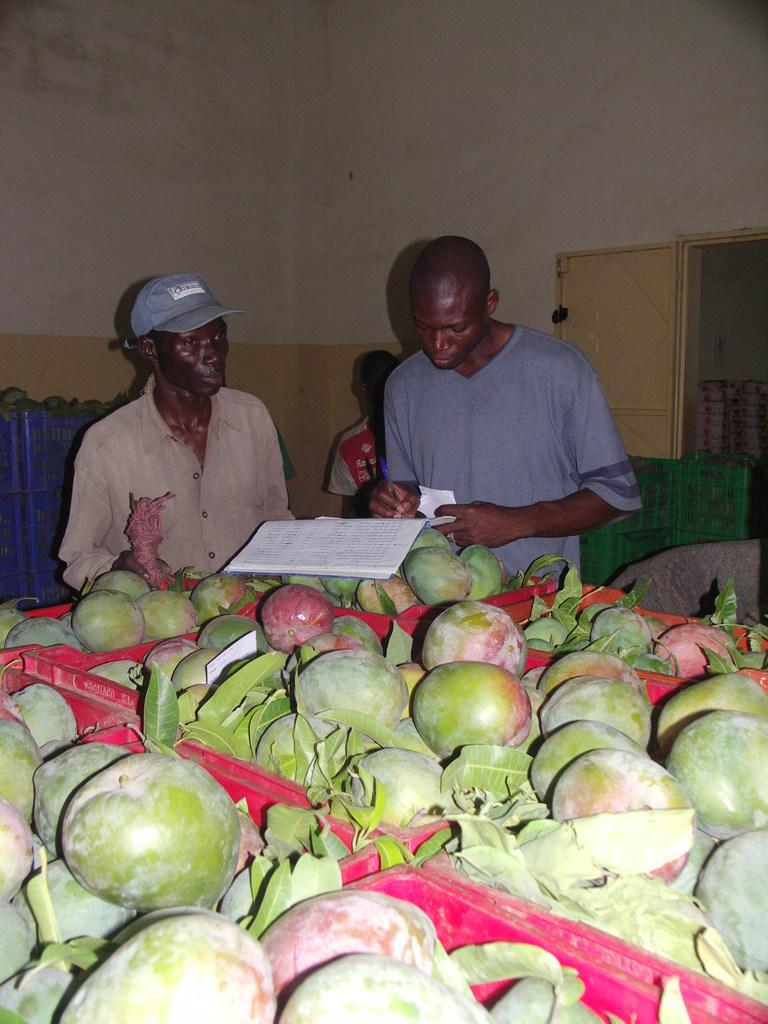How many people are in the image? There is a group of people in the image, but the exact number is not specified. What are the people doing in the image? The people are standing beside a table and writing in a book. What can be seen on the table in the image? There are raw mangoes visible on the table in the image. What type of meat is being served on the marble table in the image? There is no meat or marble table present in the image. How many letters are being written by the people in the image? The number of letters being written by the people in the image is not specified. 